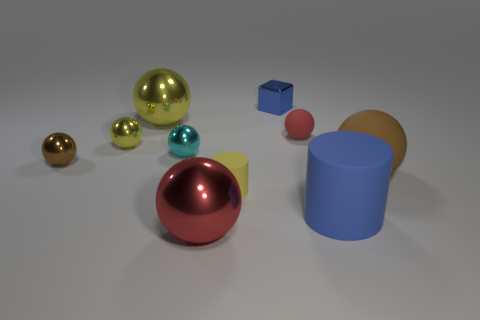There is a metal thing that is on the right side of the small cylinder; does it have the same color as the big cylinder?
Make the answer very short. Yes. The big object that is on the left side of the big brown rubber thing and behind the small cylinder has what shape?
Provide a short and direct response. Sphere. What number of small brown spheres have the same material as the tiny red thing?
Offer a very short reply. 0. Is the number of shiny things that are in front of the large yellow metallic thing less than the number of big green rubber blocks?
Make the answer very short. No. Are there any metal objects to the left of the small yellow object on the left side of the small rubber cylinder?
Give a very brief answer. Yes. Is there any other thing that is the same shape as the blue metal object?
Your response must be concise. No. Do the brown matte object and the red metal sphere have the same size?
Give a very brief answer. Yes. There is a brown thing that is on the left side of the small rubber object that is to the left of the small rubber object on the right side of the block; what is it made of?
Ensure brevity in your answer.  Metal. Are there the same number of big matte spheres that are behind the brown rubber sphere and big yellow balls?
Make the answer very short. No. What number of objects are big red shiny objects or cylinders?
Your response must be concise. 3. 